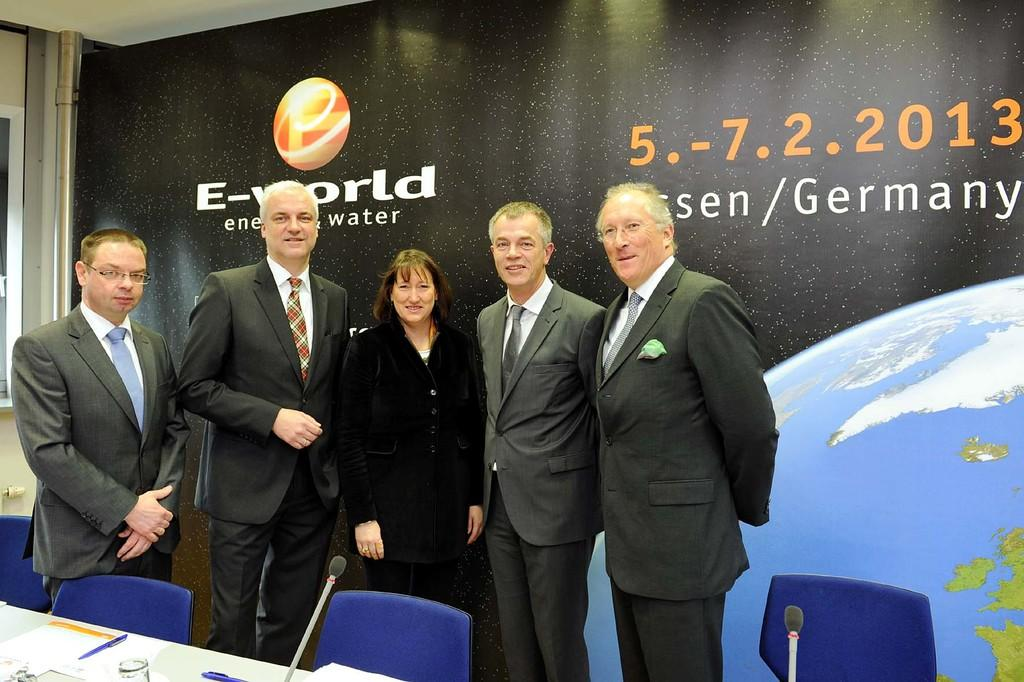How many people are in the image? There is a group of people in the image. What are the people in the image doing? The people are standing together. What furniture is present in the image? There is a table and chairs in the image. Where are the table and chairs located in relation to the group of people? The table and chairs are in front of the group of people. What can be seen on the wall behind the group of people? There is a big banner on the wall behind the group of people. How many maids are dusting the powder on the frogs in the image? There are no maids, powder, or frogs present in the image. 